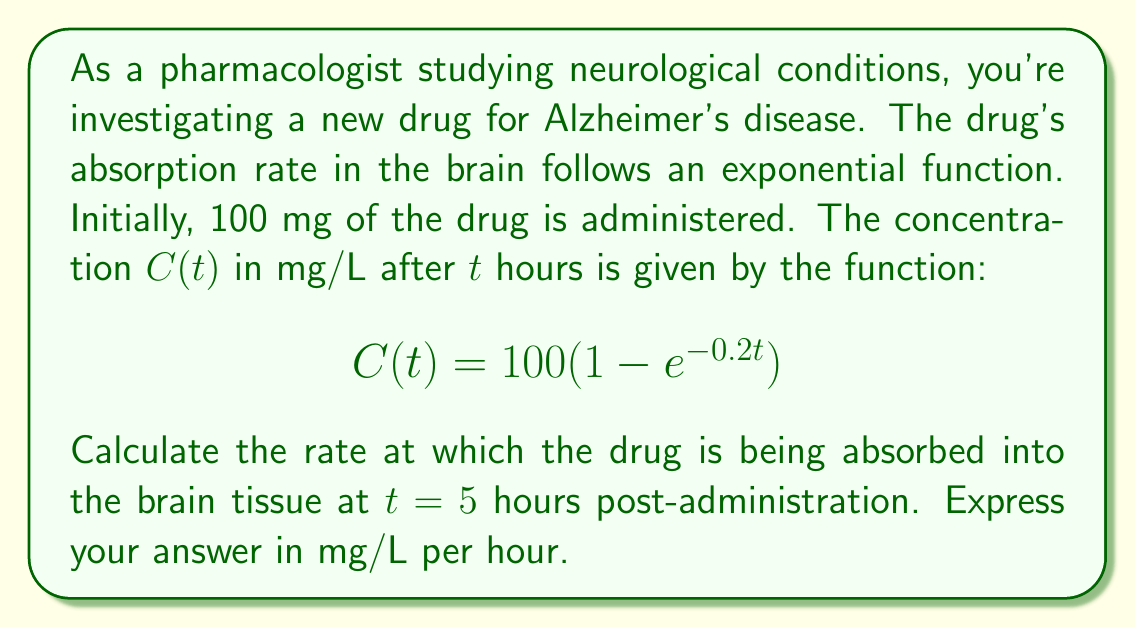Solve this math problem. To solve this problem, we need to find the instantaneous rate of change of the drug concentration at $t = 5$ hours. This is equivalent to finding the derivative of the concentration function $C(t)$ and evaluating it at $t = 5$.

Step 1: Find the derivative of $C(t)$.
$$C(t) = 100(1 - e^{-0.2t})$$
$$\frac{d}{dt}C(t) = 100 \cdot \frac{d}{dt}(1 - e^{-0.2t})$$
$$\frac{d}{dt}C(t) = 100 \cdot (-1) \cdot (-0.2e^{-0.2t})$$
$$\frac{d}{dt}C(t) = 20e^{-0.2t}$$

Step 2: Evaluate the derivative at $t = 5$.
$$\left.\frac{d}{dt}C(t)\right|_{t=5} = 20e^{-0.2(5)}$$
$$\left.\frac{d}{dt}C(t)\right|_{t=5} = 20e^{-1}$$

Step 3: Calculate the final value.
$$\left.\frac{d}{dt}C(t)\right|_{t=5} = 20 \cdot \frac{1}{e} \approx 7.3576 \text{ mg/L per hour}$$

This rate represents the instantaneous rate of drug absorption into the brain tissue at 5 hours post-administration.
Answer: The rate of drug absorption at $t = 5$ hours is approximately 7.3576 mg/L per hour. 